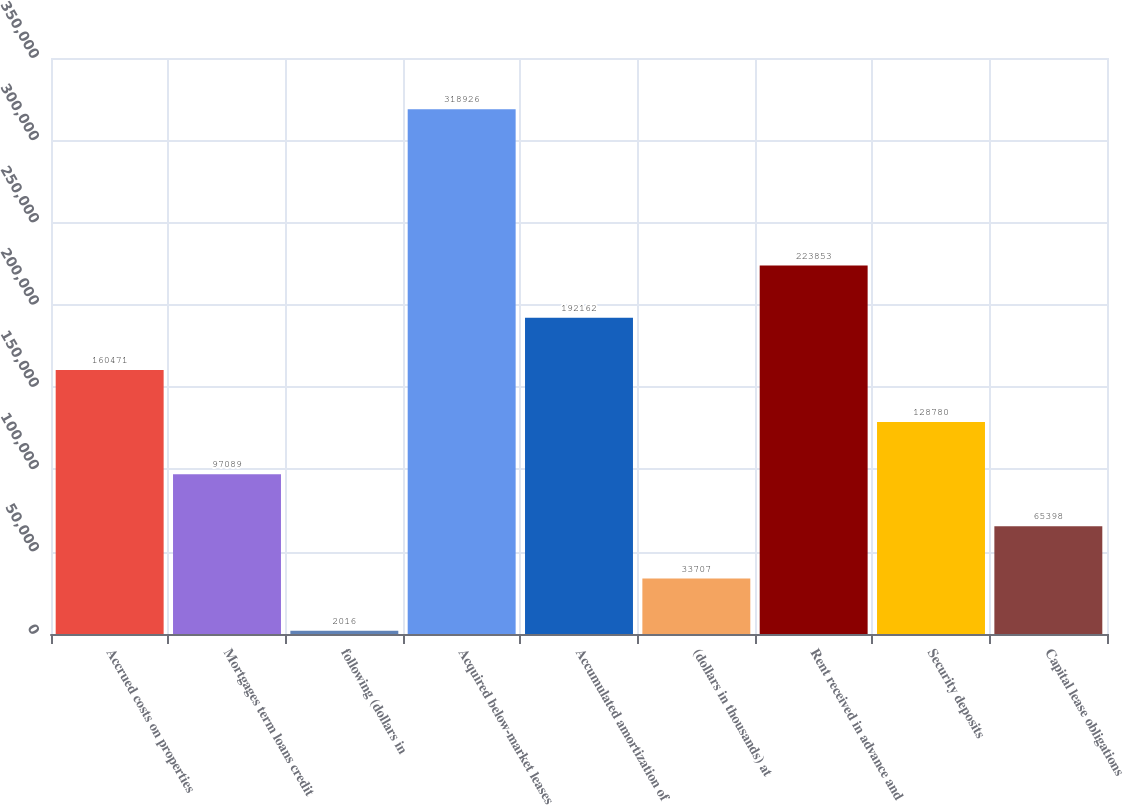Convert chart. <chart><loc_0><loc_0><loc_500><loc_500><bar_chart><fcel>Accrued costs on properties<fcel>Mortgages term loans credit<fcel>following (dollars in<fcel>Acquired below-market leases<fcel>Accumulated amortization of<fcel>(dollars in thousands) at<fcel>Rent received in advance and<fcel>Security deposits<fcel>Capital lease obligations<nl><fcel>160471<fcel>97089<fcel>2016<fcel>318926<fcel>192162<fcel>33707<fcel>223853<fcel>128780<fcel>65398<nl></chart> 